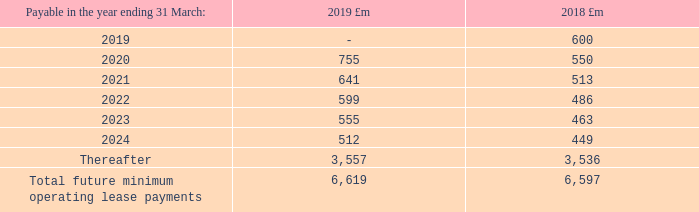Future minimum operating lease payments were as follows:
Operating lease commitments were mainly in respect of land and buildings which arose from a sale and operating leaseback transaction in 2001. Leases have an average term of 13 years (2017/18: 14 years) and rentals are fixed for an average of 13 years (2017/18: 14 years).
Other than as disclosed below, there were no contingent liabilities or guarantees at 31 March 2018 other than those arising in the ordinary course of the group’s business and on these no material losses are anticipated. We have insurance cover to certain limits for major risks on property and major claims in connection with legal liabilities arising in the course of our operations. Otherwise, the group generally carries its own risks.
What was the average term of leases in 2019 and 2018 respectively? 13 years, 14 years. What are the contingent liabilities or guarantees at 31 March 2018? There were no contingent liabilities or guarantees at 31 march 2018. What was the payable in the year ending 31 March 2019 for 2018?
Answer scale should be: million. 600. What was the difference in the payables in year 31 March 2019 for 2018 and 2019?
Answer scale should be: million. 600-0
Answer: 600. For which year was  the  Total future minimum operating lease payments be higher? Compare the  Total future minimum operating lease payments  for the larger value
Answer: 2019. Which year from 2019 to 2024 had the largest payable amount for 2018? Find the largest number for 2019 to 2024 for 2018 payment
Answer: 2020. 